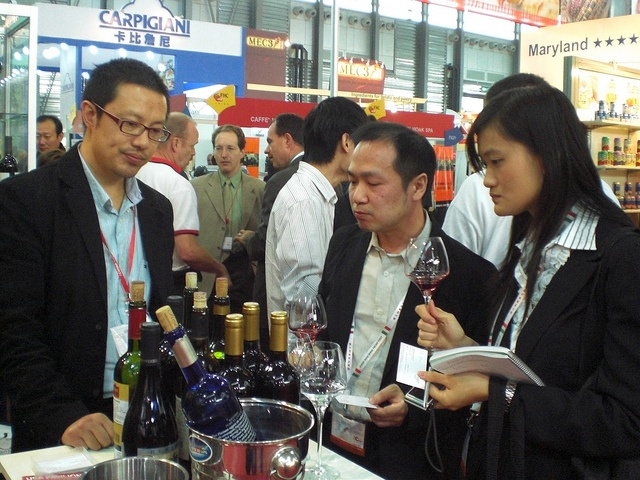Describe the objects in this image and their specific colors. I can see people in darkgray, black, gray, and tan tones, people in darkgray, black, gray, and tan tones, people in darkgray, black, and gray tones, people in darkgray, lightgray, black, and gray tones, and people in darkgray, gray, and black tones in this image. 